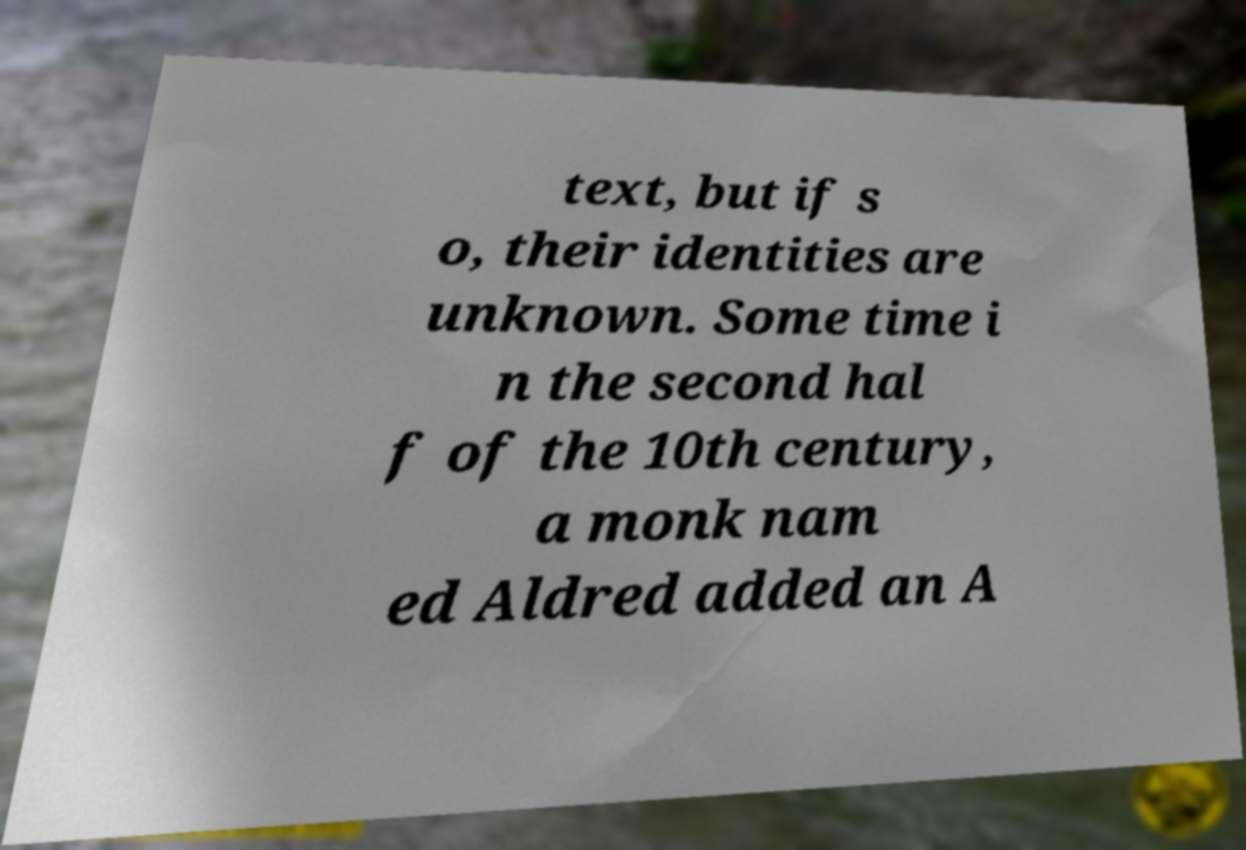Can you read and provide the text displayed in the image?This photo seems to have some interesting text. Can you extract and type it out for me? text, but if s o, their identities are unknown. Some time i n the second hal f of the 10th century, a monk nam ed Aldred added an A 